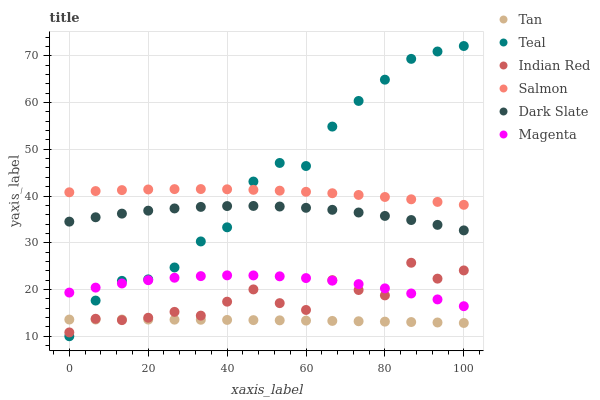Does Tan have the minimum area under the curve?
Answer yes or no. Yes. Does Teal have the maximum area under the curve?
Answer yes or no. Yes. Does Salmon have the minimum area under the curve?
Answer yes or no. No. Does Salmon have the maximum area under the curve?
Answer yes or no. No. Is Tan the smoothest?
Answer yes or no. Yes. Is Indian Red the roughest?
Answer yes or no. Yes. Is Salmon the smoothest?
Answer yes or no. No. Is Salmon the roughest?
Answer yes or no. No. Does Teal have the lowest value?
Answer yes or no. Yes. Does Dark Slate have the lowest value?
Answer yes or no. No. Does Teal have the highest value?
Answer yes or no. Yes. Does Salmon have the highest value?
Answer yes or no. No. Is Tan less than Dark Slate?
Answer yes or no. Yes. Is Dark Slate greater than Magenta?
Answer yes or no. Yes. Does Indian Red intersect Teal?
Answer yes or no. Yes. Is Indian Red less than Teal?
Answer yes or no. No. Is Indian Red greater than Teal?
Answer yes or no. No. Does Tan intersect Dark Slate?
Answer yes or no. No. 